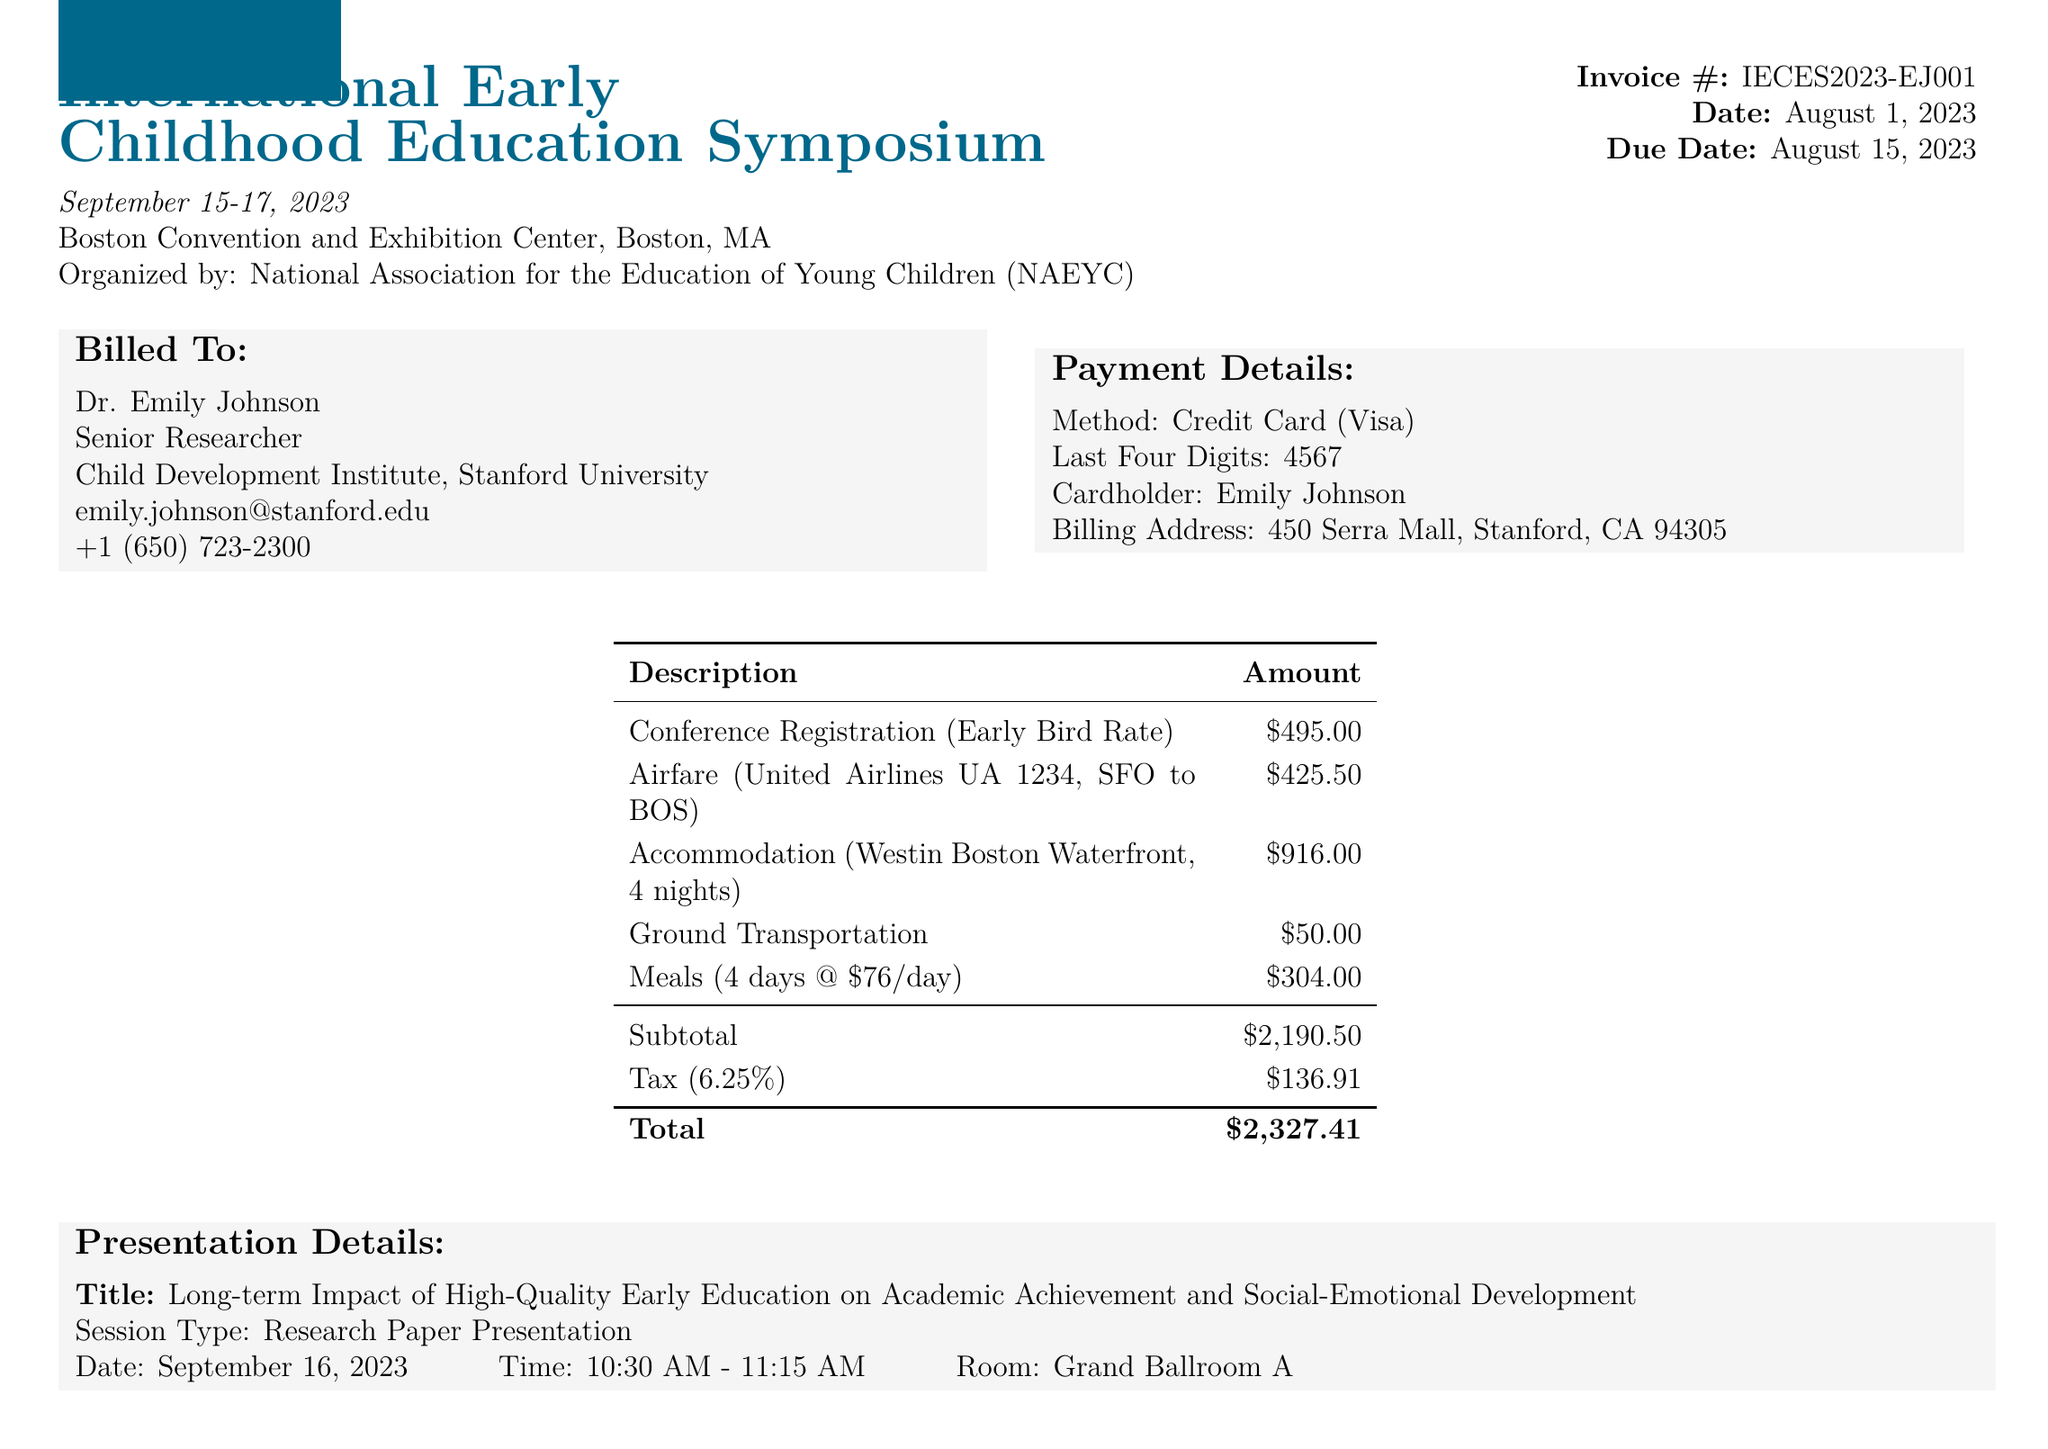What is the name of the conference? The conference name is listed at the top of the document under the event details section.
Answer: International Early Childhood Education Symposium What is the early bird registration fee? The registration fee section specifies the early bird rate for the conference.
Answer: 495.00 Who is presenting the research? The attendee information section specifies the name of the person presenting their findings.
Answer: Dr. Emily Johnson What is the total amount due on the invoice? The total amount is shown at the bottom of the invoice section, after subtotal and tax.
Answer: 2327.41 What is the check-in date for the accommodation? The accommodation section lists the check-in date.
Answer: September 14, 2023 What is the presentation title? The presentation details section specifies the title of the research being presented.
Answer: Long-term Impact of High-Quality Early Education on Academic Achievement and Social-Emotional Development How many nights is the accommodation booked for? The accommodation section indicates the number of nights the hotel stay spans.
Answer: 4 What is the invoice number? The invoice number is provided near the top of the document under invoice details.
Answer: IECES2023-EJ001 When is the payment due date? The due date for the payment is specified in the invoice details section.
Answer: August 15, 2023 